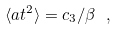<formula> <loc_0><loc_0><loc_500><loc_500>\langle a t ^ { 2 } \rangle = c _ { 3 } / \beta \ ,</formula> 